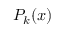Convert formula to latex. <formula><loc_0><loc_0><loc_500><loc_500>P _ { k } ( x )</formula> 